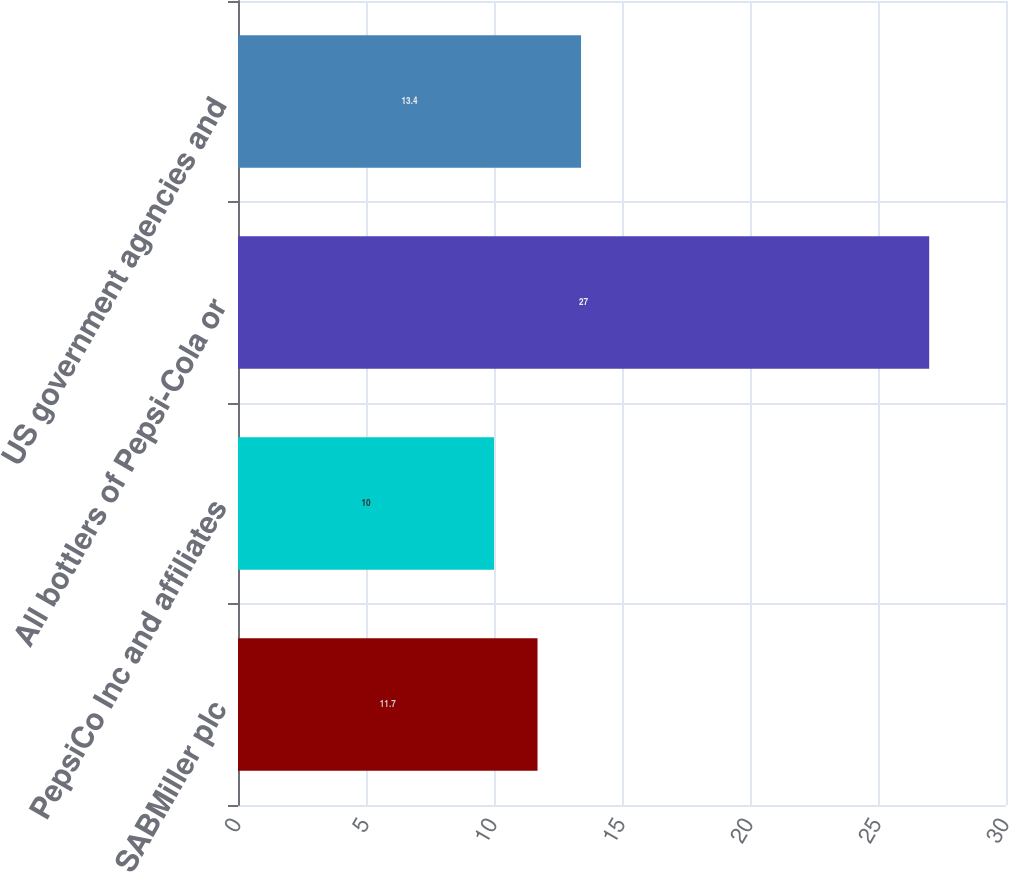Convert chart. <chart><loc_0><loc_0><loc_500><loc_500><bar_chart><fcel>SABMiller plc<fcel>PepsiCo Inc and affiliates<fcel>All bottlers of Pepsi-Cola or<fcel>US government agencies and<nl><fcel>11.7<fcel>10<fcel>27<fcel>13.4<nl></chart> 